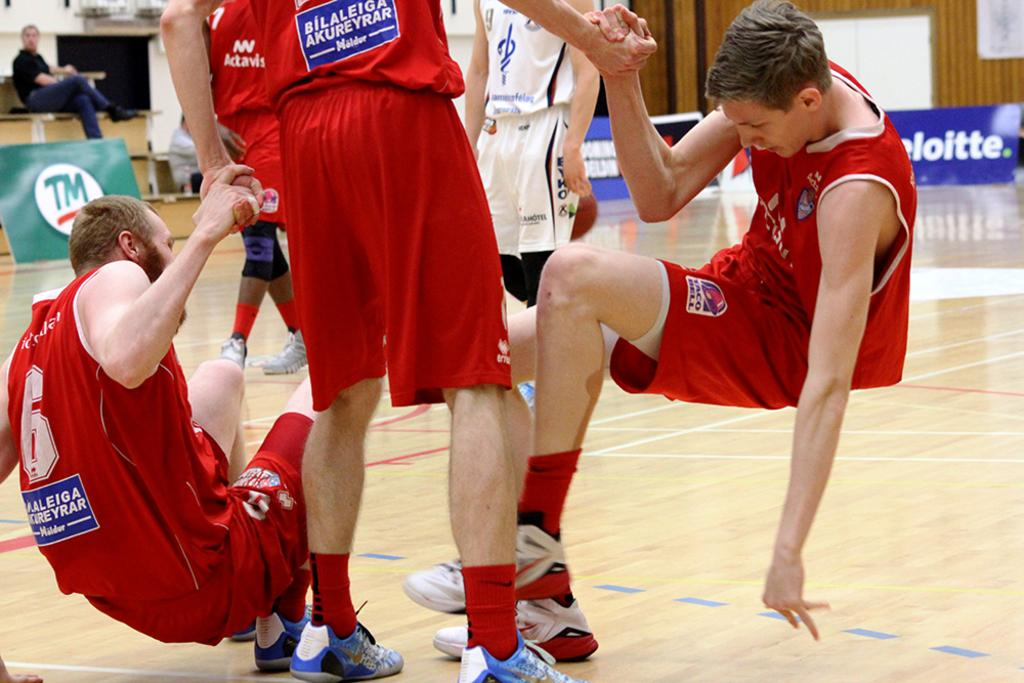Provide a one-sentence caption for the provided image. A young man in basketball uniform helping two teammates up from the ground at a basketball game sponsored by Deloitte. 